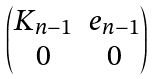Convert formula to latex. <formula><loc_0><loc_0><loc_500><loc_500>\begin{pmatrix} K _ { n - 1 } & e _ { n - 1 } \\ 0 & 0 \end{pmatrix}</formula> 